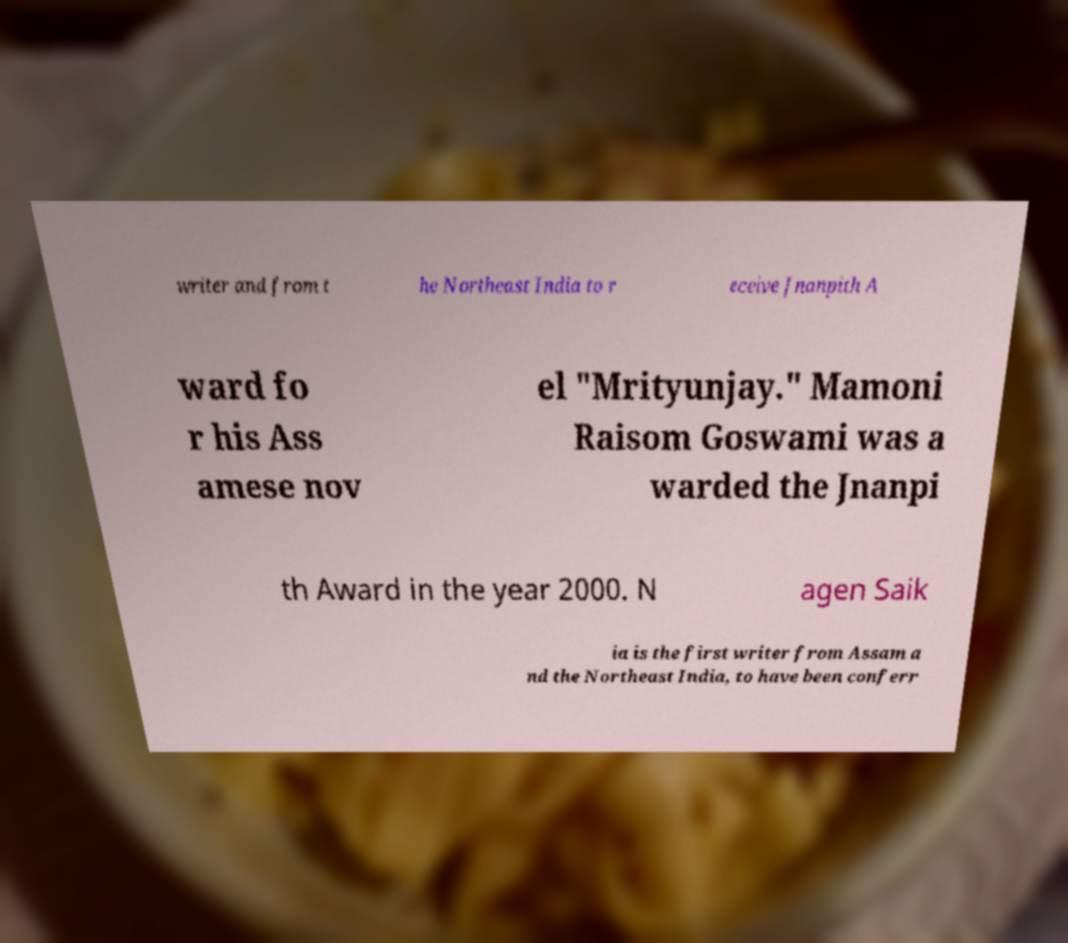Can you accurately transcribe the text from the provided image for me? writer and from t he Northeast India to r eceive Jnanpith A ward fo r his Ass amese nov el "Mrityunjay." Mamoni Raisom Goswami was a warded the Jnanpi th Award in the year 2000. N agen Saik ia is the first writer from Assam a nd the Northeast India, to have been conferr 